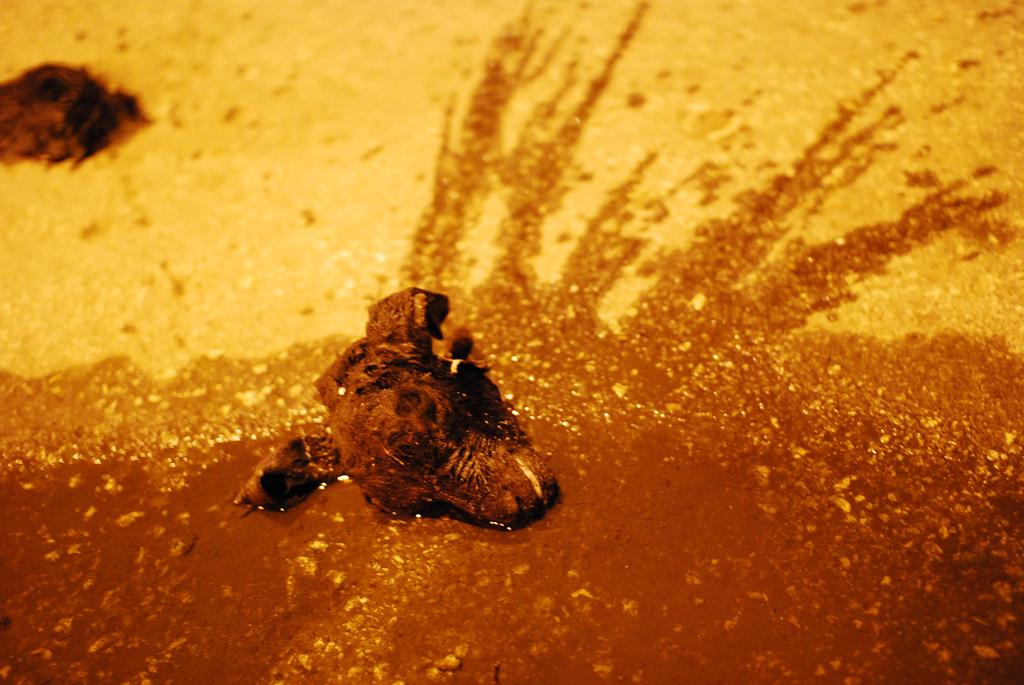What is the main subject in the foreground of the image? There is a head of an animal in the foreground of the image. How many cups are stacked on top of the rock in the image? There is no rock or cup present in the image; it only features the head of an animal. 